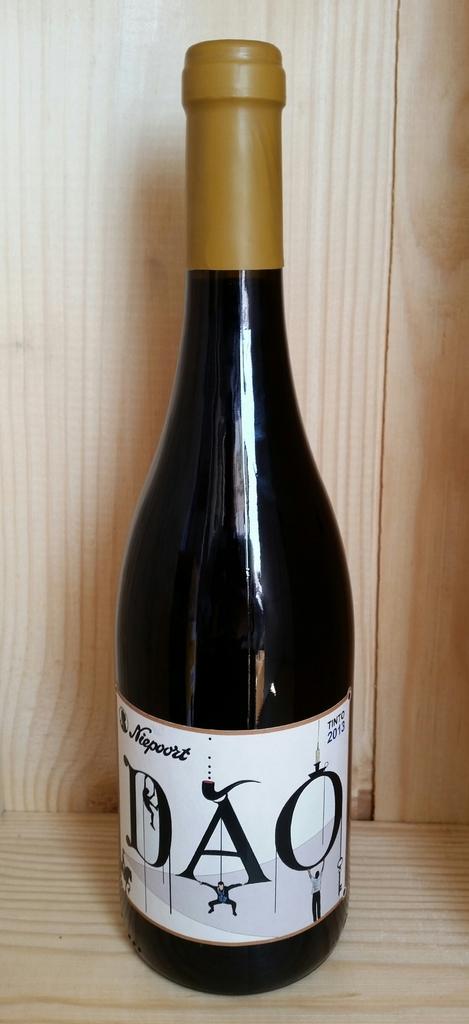What is the name of this wine?
Make the answer very short. Dao. What is the year on the label?
Offer a very short reply. 2013. 